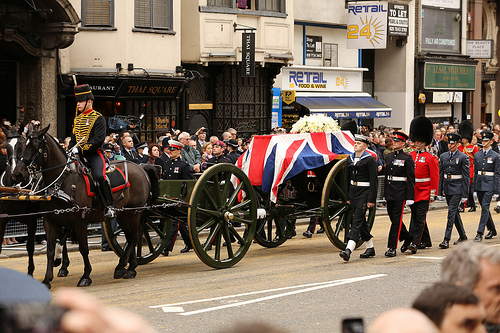What is the green vehicle in the picture? The green vehicle in the picture is a wagon. 